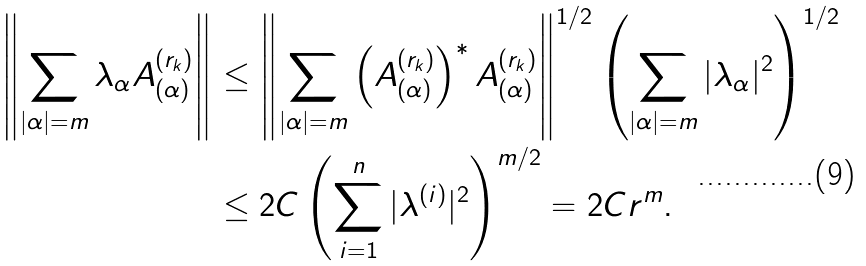<formula> <loc_0><loc_0><loc_500><loc_500>\left \| \sum _ { | \alpha | = m } \lambda _ { \alpha } A _ { ( \alpha ) } ^ { ( r _ { k } ) } \right \| & \leq \left \| \sum _ { | \alpha | = m } \left ( A _ { ( \alpha ) } ^ { ( r _ { k } ) } \right ) ^ { * } A _ { ( \alpha ) } ^ { ( r _ { k } ) } \right \| ^ { 1 / 2 } \left ( \sum _ { | \alpha | = m } | \lambda _ { \alpha } | ^ { 2 } \right ) ^ { 1 / 2 } \\ & \leq 2 C \left ( \sum _ { i = 1 } ^ { n } | \lambda ^ { ( i ) } | ^ { 2 } \right ) ^ { m / 2 } = 2 C r ^ { m } .</formula> 